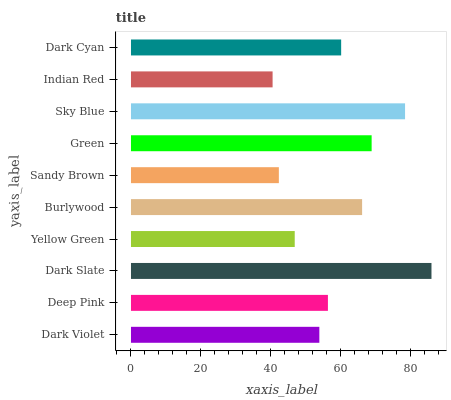Is Indian Red the minimum?
Answer yes or no. Yes. Is Dark Slate the maximum?
Answer yes or no. Yes. Is Deep Pink the minimum?
Answer yes or no. No. Is Deep Pink the maximum?
Answer yes or no. No. Is Deep Pink greater than Dark Violet?
Answer yes or no. Yes. Is Dark Violet less than Deep Pink?
Answer yes or no. Yes. Is Dark Violet greater than Deep Pink?
Answer yes or no. No. Is Deep Pink less than Dark Violet?
Answer yes or no. No. Is Dark Cyan the high median?
Answer yes or no. Yes. Is Deep Pink the low median?
Answer yes or no. Yes. Is Deep Pink the high median?
Answer yes or no. No. Is Sky Blue the low median?
Answer yes or no. No. 